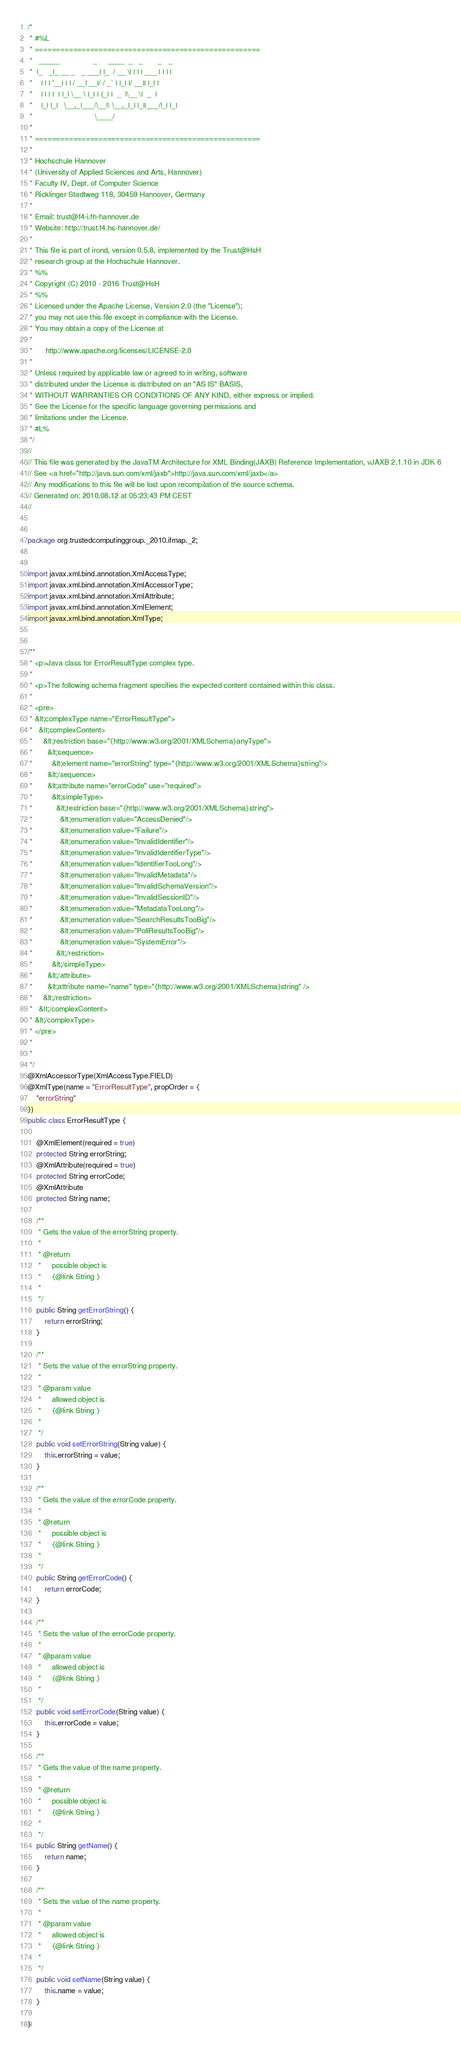Convert code to text. <code><loc_0><loc_0><loc_500><loc_500><_Java_>/*
 * #%L
 * =====================================================
 *   _____                _     ____  _   _       _   _
 *  |_   _|_ __ _   _ ___| |_  / __ \| | | | ___ | | | |
 *    | | | '__| | | / __| __|/ / _` | |_| |/ __|| |_| |
 *    | | | |  | |_| \__ \ |_| | (_| |  _  |\__ \|  _  |
 *    |_| |_|   \__,_|___/\__|\ \__,_|_| |_||___/|_| |_|
 *                             \____/
 * 
 * =====================================================
 * 
 * Hochschule Hannover
 * (University of Applied Sciences and Arts, Hannover)
 * Faculty IV, Dept. of Computer Science
 * Ricklinger Stadtweg 118, 30459 Hannover, Germany
 * 
 * Email: trust@f4-i.fh-hannover.de
 * Website: http://trust.f4.hs-hannover.de/
 * 
 * This file is part of irond, version 0.5.8, implemented by the Trust@HsH
 * research group at the Hochschule Hannover.
 * %%
 * Copyright (C) 2010 - 2016 Trust@HsH
 * %%
 * Licensed under the Apache License, Version 2.0 (the "License");
 * you may not use this file except in compliance with the License.
 * You may obtain a copy of the License at
 * 
 *      http://www.apache.org/licenses/LICENSE-2.0
 * 
 * Unless required by applicable law or agreed to in writing, software
 * distributed under the License is distributed on an "AS IS" BASIS,
 * WITHOUT WARRANTIES OR CONDITIONS OF ANY KIND, either express or implied.
 * See the License for the specific language governing permissions and
 * limitations under the License.
 * #L%
 */
//
// This file was generated by the JavaTM Architecture for XML Binding(JAXB) Reference Implementation, vJAXB 2.1.10 in JDK 6
// See <a href="http://java.sun.com/xml/jaxb">http://java.sun.com/xml/jaxb</a>
// Any modifications to this file will be lost upon recompilation of the source schema.
// Generated on: 2010.08.12 at 05:23:43 PM CEST
//


package org.trustedcomputinggroup._2010.ifmap._2;


import javax.xml.bind.annotation.XmlAccessType;
import javax.xml.bind.annotation.XmlAccessorType;
import javax.xml.bind.annotation.XmlAttribute;
import javax.xml.bind.annotation.XmlElement;
import javax.xml.bind.annotation.XmlType;


/**
 * <p>Java class for ErrorResultType complex type.
 *
 * <p>The following schema fragment specifies the expected content contained within this class.
 *
 * <pre>
 * &lt;complexType name="ErrorResultType">
 *   &lt;complexContent>
 *     &lt;restriction base="{http://www.w3.org/2001/XMLSchema}anyType">
 *       &lt;sequence>
 *         &lt;element name="errorString" type="{http://www.w3.org/2001/XMLSchema}string"/>
 *       &lt;/sequence>
 *       &lt;attribute name="errorCode" use="required">
 *         &lt;simpleType>
 *           &lt;restriction base="{http://www.w3.org/2001/XMLSchema}string">
 *             &lt;enumeration value="AccessDenied"/>
 *             &lt;enumeration value="Failure"/>
 *             &lt;enumeration value="InvalidIdentifier"/>
 *             &lt;enumeration value="InvalidIdentifierType"/>
 *             &lt;enumeration value="IdentifierTooLong"/>
 *             &lt;enumeration value="InvalidMetadata"/>
 *             &lt;enumeration value="InvalidSchemaVersion"/>
 *             &lt;enumeration value="InvalidSessionID"/>
 *             &lt;enumeration value="MetadataTooLong"/>
 *             &lt;enumeration value="SearchResultsTooBig"/>
 *             &lt;enumeration value="PollResultsTooBig"/>
 *             &lt;enumeration value="SystemError"/>
 *           &lt;/restriction>
 *         &lt;/simpleType>
 *       &lt;/attribute>
 *       &lt;attribute name="name" type="{http://www.w3.org/2001/XMLSchema}string" />
 *     &lt;/restriction>
 *   &lt;/complexContent>
 * &lt;/complexType>
 * </pre>
 *
 *
 */
@XmlAccessorType(XmlAccessType.FIELD)
@XmlType(name = "ErrorResultType", propOrder = {
    "errorString"
})
public class ErrorResultType {

    @XmlElement(required = true)
    protected String errorString;
    @XmlAttribute(required = true)
    protected String errorCode;
    @XmlAttribute
    protected String name;

    /**
     * Gets the value of the errorString property.
     *
     * @return
     *     possible object is
     *     {@link String }
     *
     */
    public String getErrorString() {
        return errorString;
    }

    /**
     * Sets the value of the errorString property.
     *
     * @param value
     *     allowed object is
     *     {@link String }
     *
     */
    public void setErrorString(String value) {
        this.errorString = value;
    }

    /**
     * Gets the value of the errorCode property.
     *
     * @return
     *     possible object is
     *     {@link String }
     *
     */
    public String getErrorCode() {
        return errorCode;
    }

    /**
     * Sets the value of the errorCode property.
     *
     * @param value
     *     allowed object is
     *     {@link String }
     *
     */
    public void setErrorCode(String value) {
        this.errorCode = value;
    }

    /**
     * Gets the value of the name property.
     *
     * @return
     *     possible object is
     *     {@link String }
     *
     */
    public String getName() {
        return name;
    }

    /**
     * Sets the value of the name property.
     *
     * @param value
     *     allowed object is
     *     {@link String }
     *
     */
    public void setName(String value) {
        this.name = value;
    }

}
</code> 